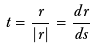<formula> <loc_0><loc_0><loc_500><loc_500>\vec { t } = \frac { \dot { \vec { r } } } { | \dot { \vec { r } } | } = \frac { d \vec { r } } { d s }</formula> 